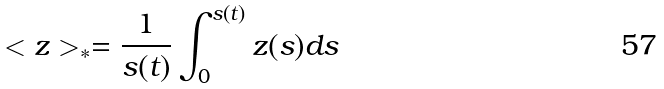Convert formula to latex. <formula><loc_0><loc_0><loc_500><loc_500>< z > _ { * } = \frac { 1 } { s ( t ) } \int _ { 0 } ^ { s ( t ) } { z ( s ) d s }</formula> 